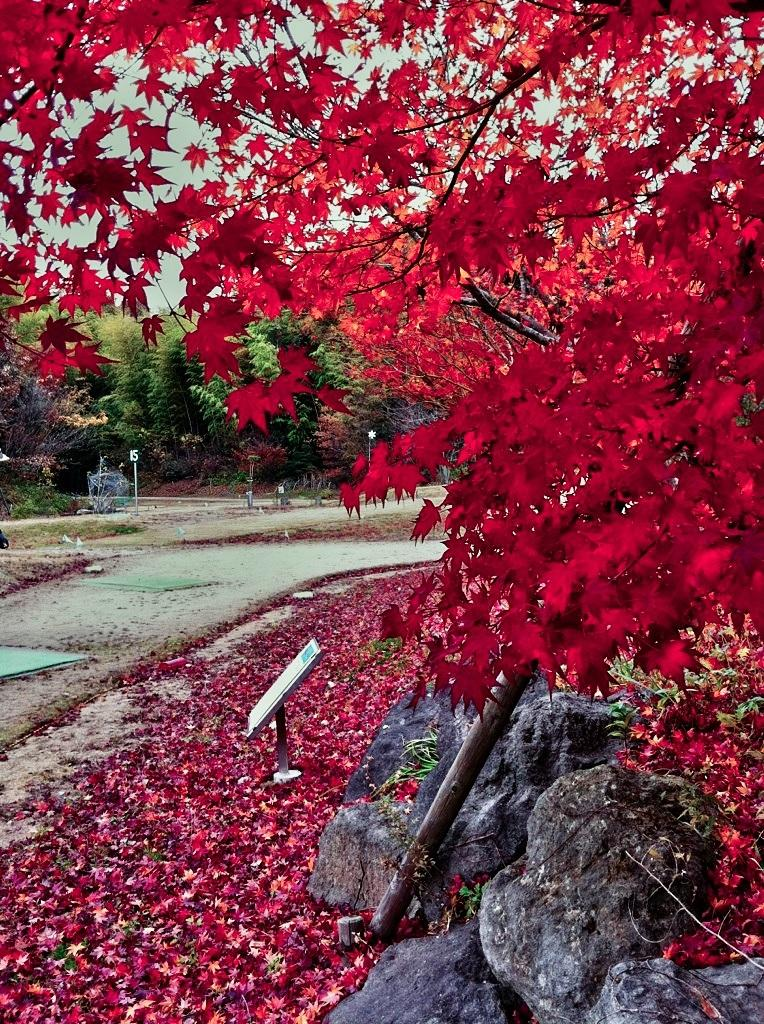What type of natural elements can be seen in the image? There are trees and rocks in the image. What else can be found on the ground in the image? There are other objects on the ground in the image. What is visible in the background of the image? The sky is visible in the background of the image. What type of operation is being performed on the sand in the image? There is no sand present in the image, so no operation can be performed on it. 